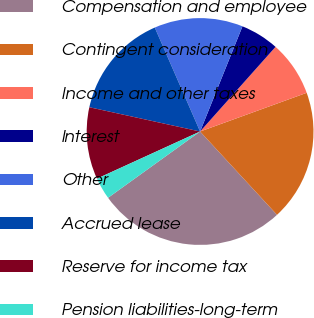Convert chart. <chart><loc_0><loc_0><loc_500><loc_500><pie_chart><fcel>Compensation and employee<fcel>Contingent consideration<fcel>Income and other taxes<fcel>Interest<fcel>Other<fcel>Accrued lease<fcel>Reserve for income tax<fcel>Pension liabilities-long-term<nl><fcel>26.93%<fcel>18.68%<fcel>7.87%<fcel>5.49%<fcel>12.64%<fcel>15.02%<fcel>10.26%<fcel>3.11%<nl></chart> 